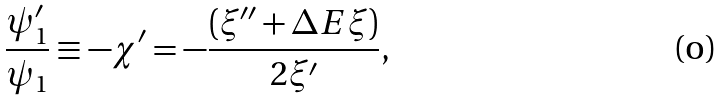Convert formula to latex. <formula><loc_0><loc_0><loc_500><loc_500>\frac { \psi _ { 1 } ^ { \prime } } { \psi _ { 1 } } \equiv - \chi ^ { \prime } = - \frac { ( \xi ^ { \prime \prime } + \Delta E \xi ) } { 2 \xi ^ { \prime } } \text {, }</formula> 